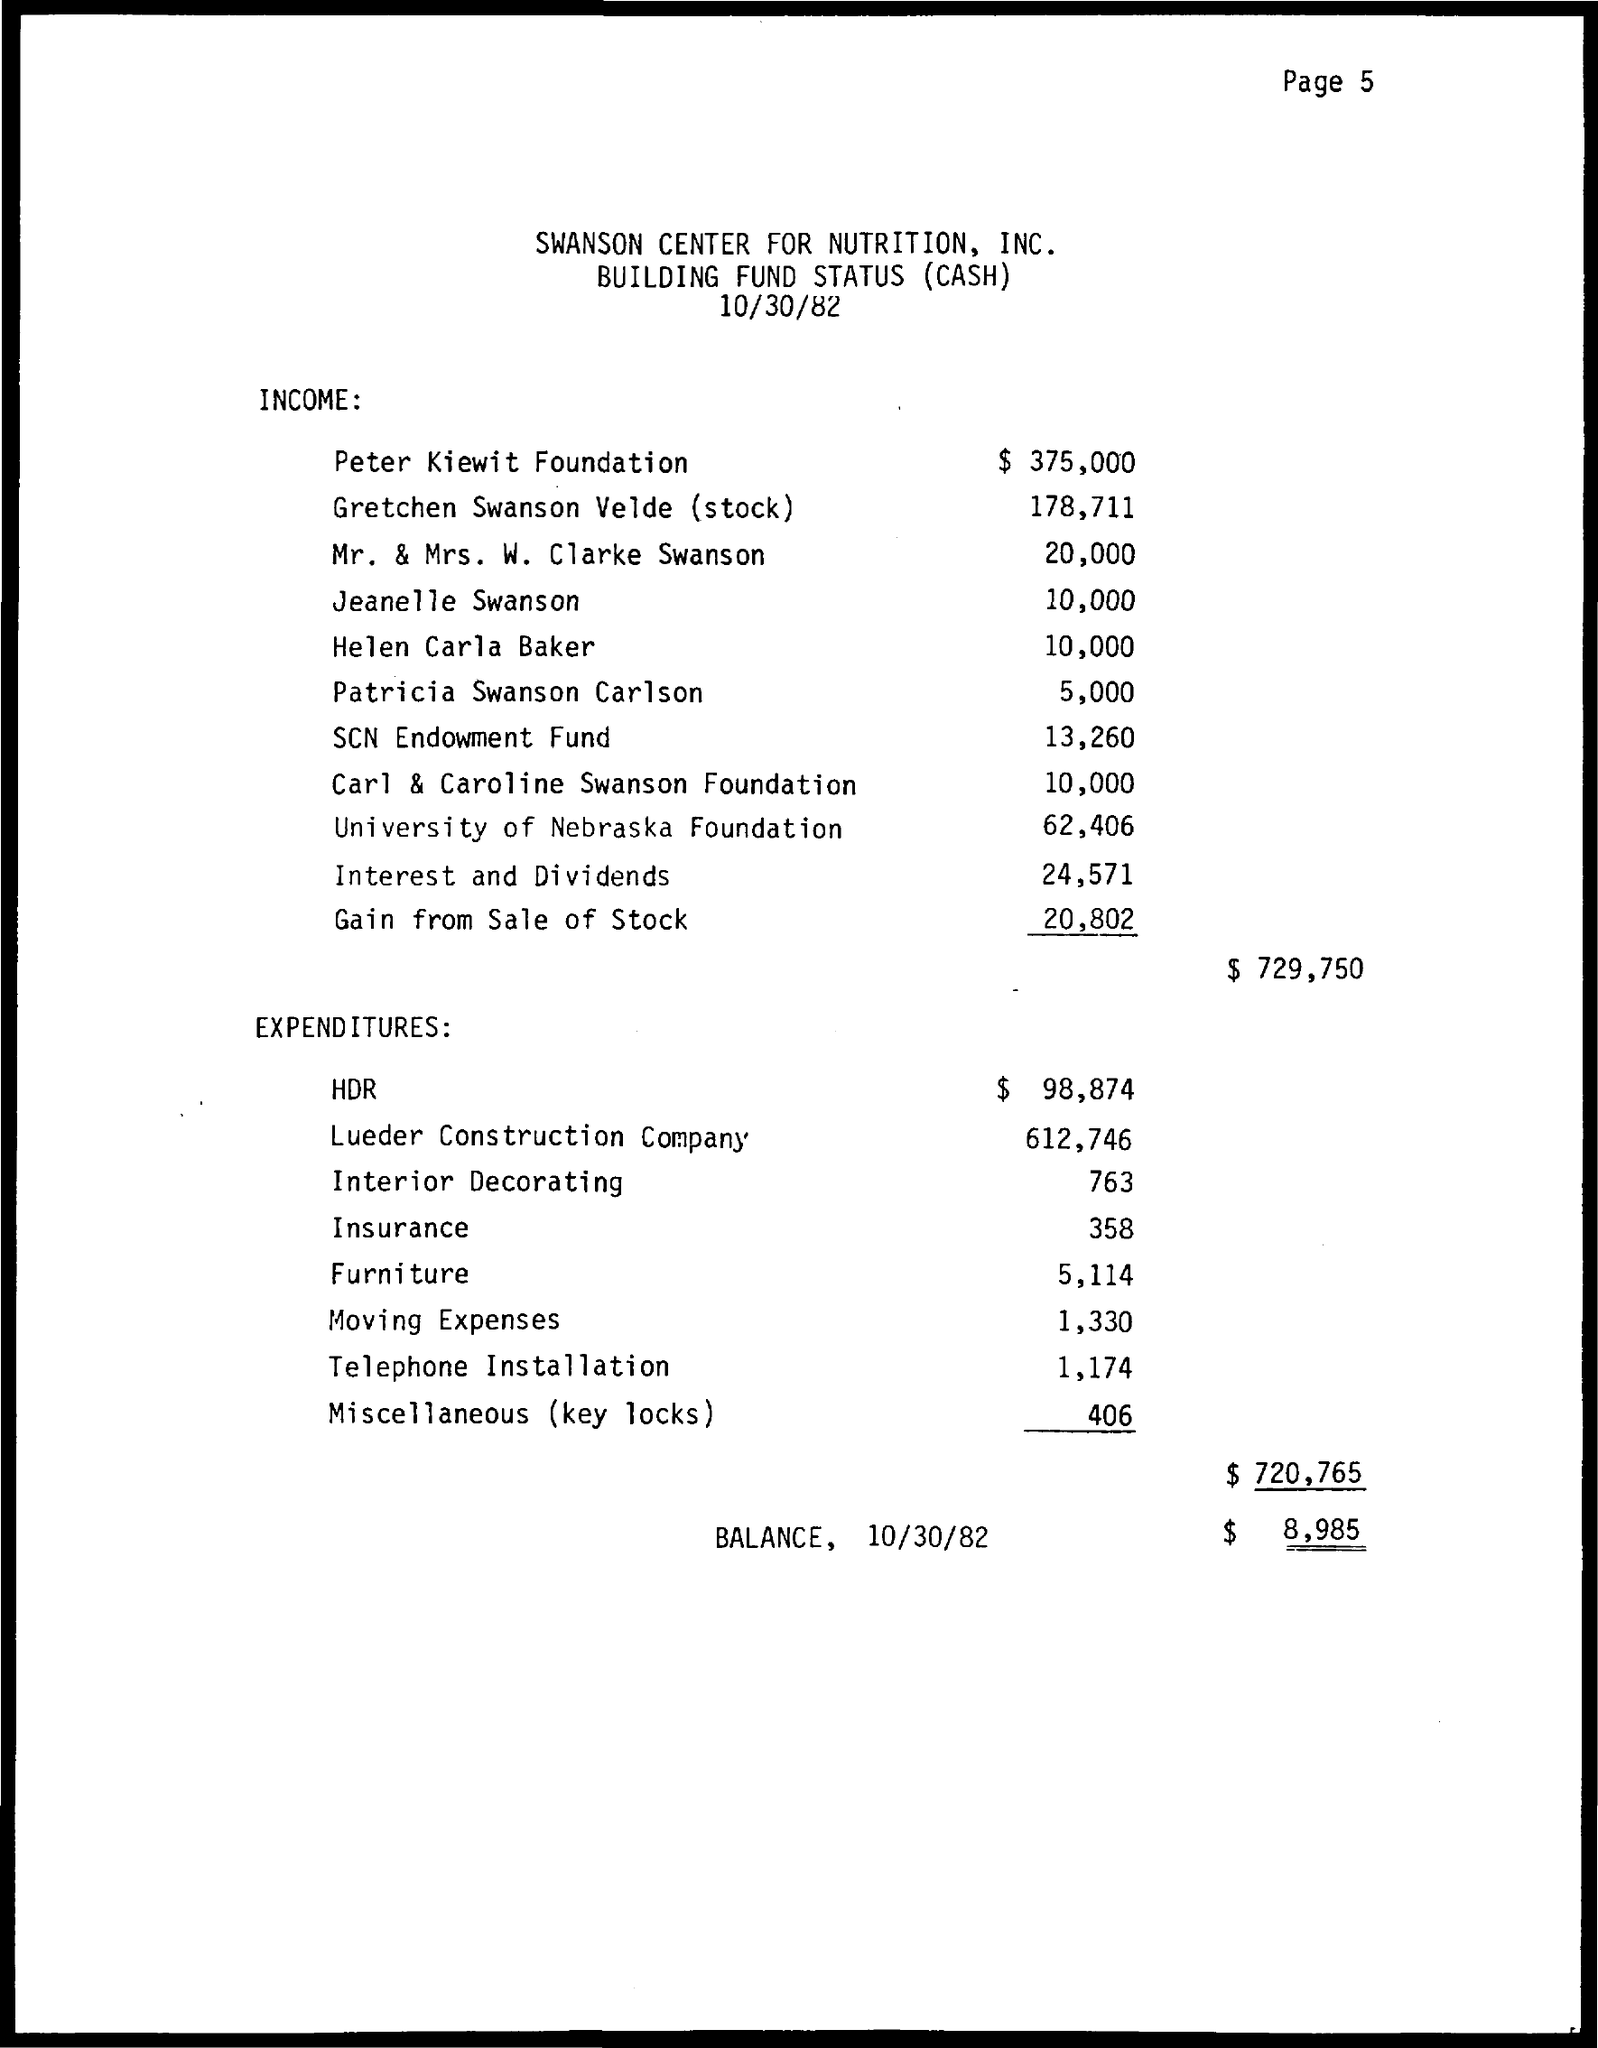Outline some significant characteristics in this image. The date mentioned in the document is October 30, 1982. The organization given in the title is the Swanson Center for Nutrition, Inc. 